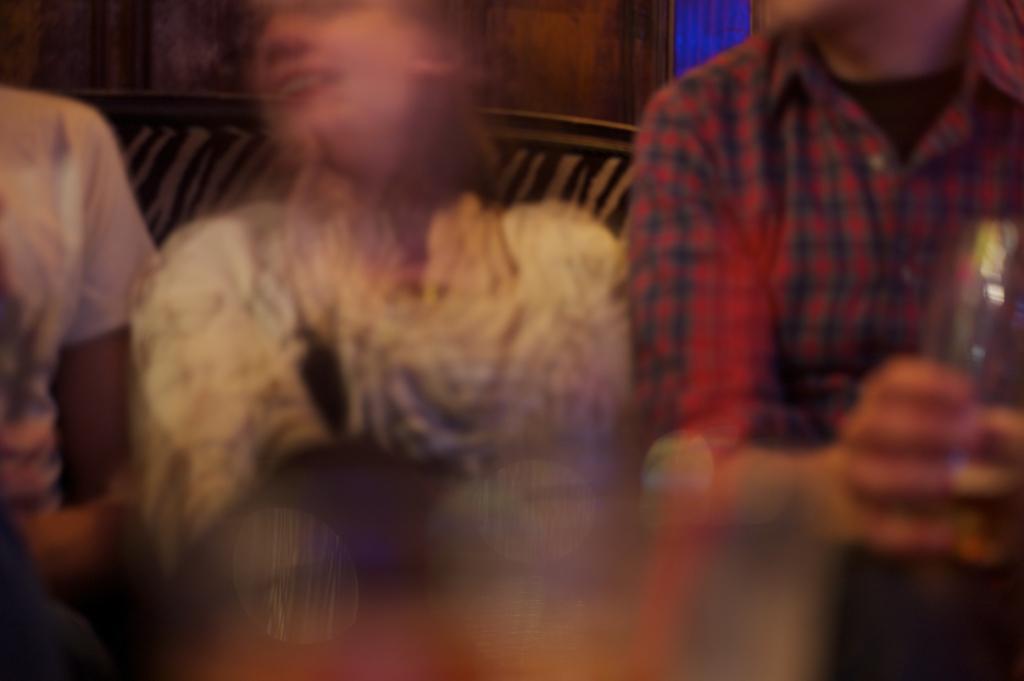Can you describe this image briefly? This is a slightly blur picture. I can see three persons sitting on the couch, and in the background there is a wall. 